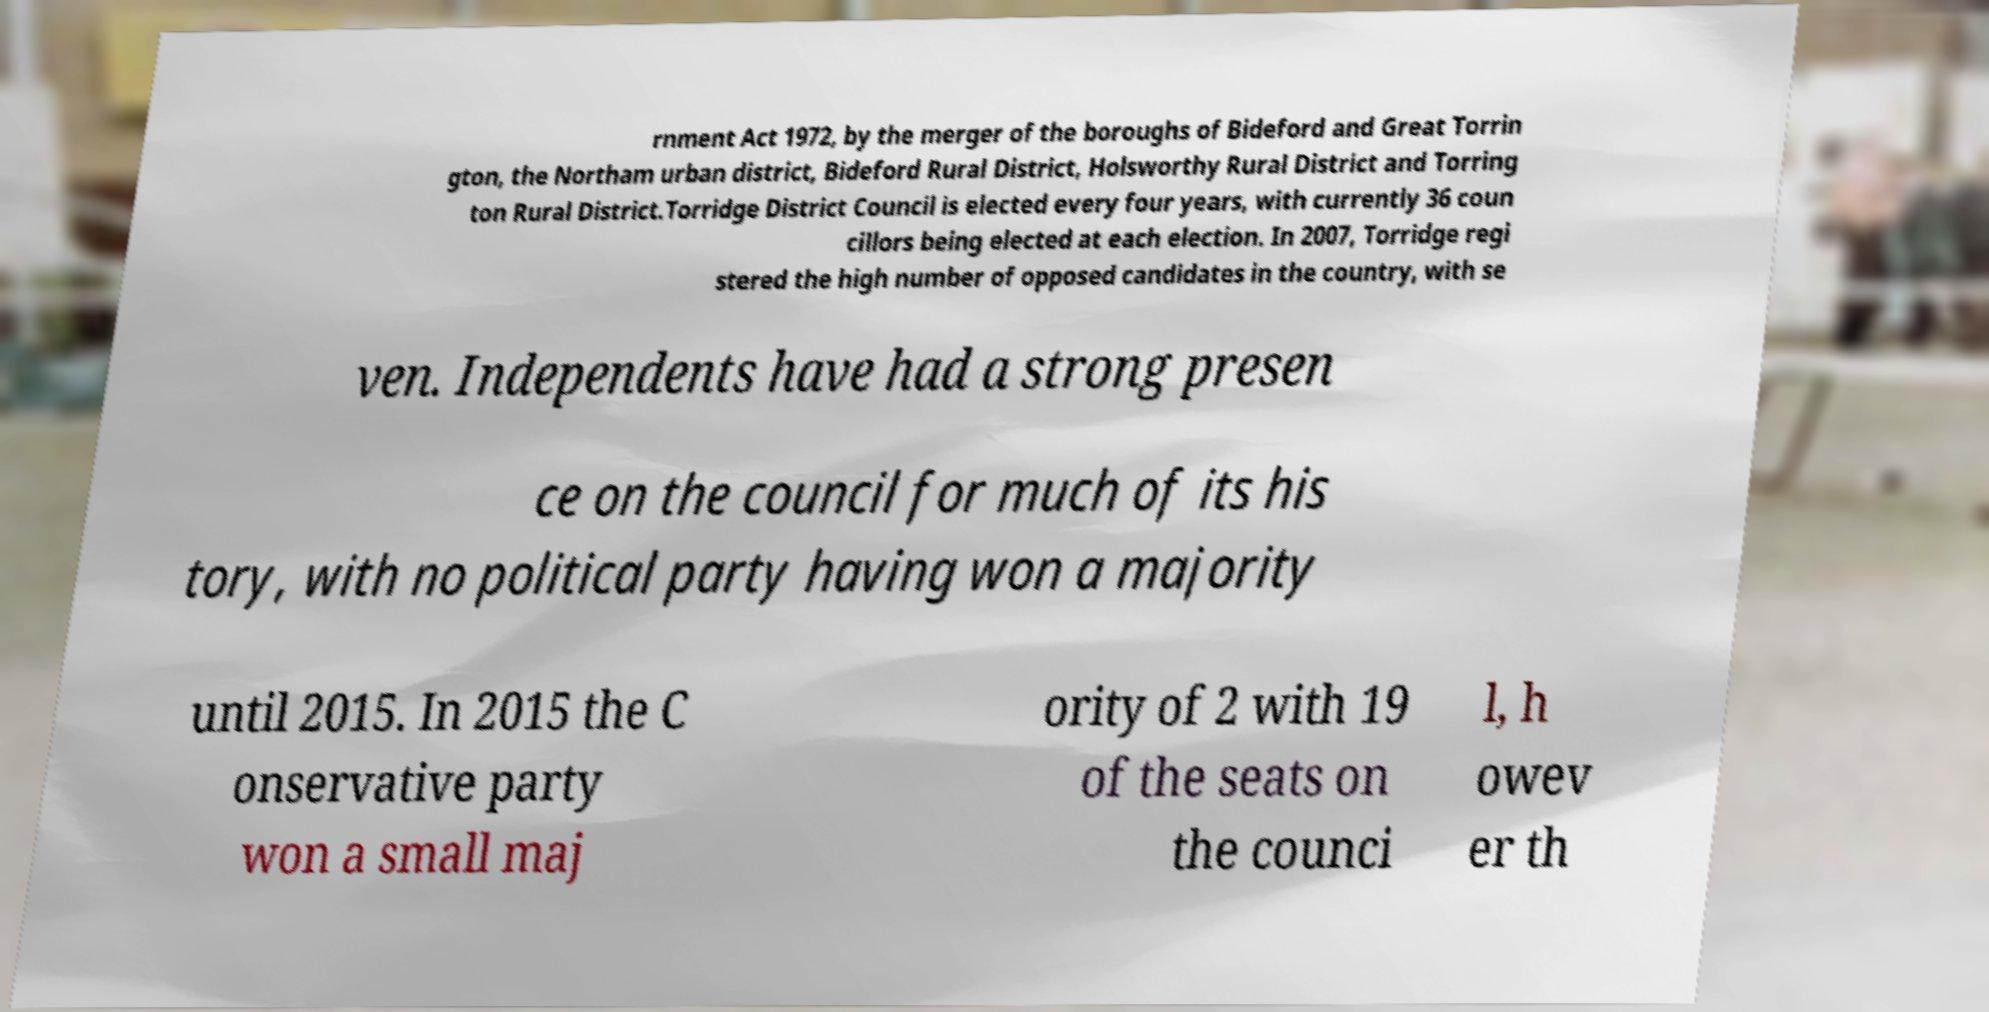Can you read and provide the text displayed in the image?This photo seems to have some interesting text. Can you extract and type it out for me? rnment Act 1972, by the merger of the boroughs of Bideford and Great Torrin gton, the Northam urban district, Bideford Rural District, Holsworthy Rural District and Torring ton Rural District.Torridge District Council is elected every four years, with currently 36 coun cillors being elected at each election. In 2007, Torridge regi stered the high number of opposed candidates in the country, with se ven. Independents have had a strong presen ce on the council for much of its his tory, with no political party having won a majority until 2015. In 2015 the C onservative party won a small maj ority of 2 with 19 of the seats on the counci l, h owev er th 